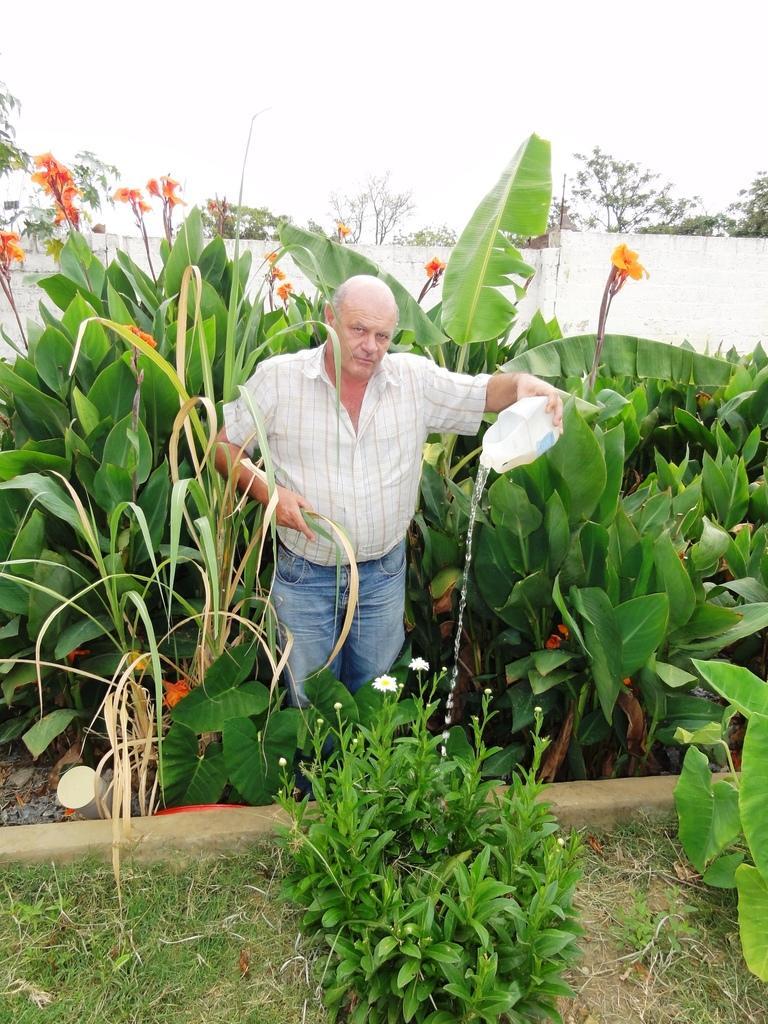Can you describe this image briefly? In this picture we can see the man standing in the front and watering the plants. Behind we can see some green plants. 